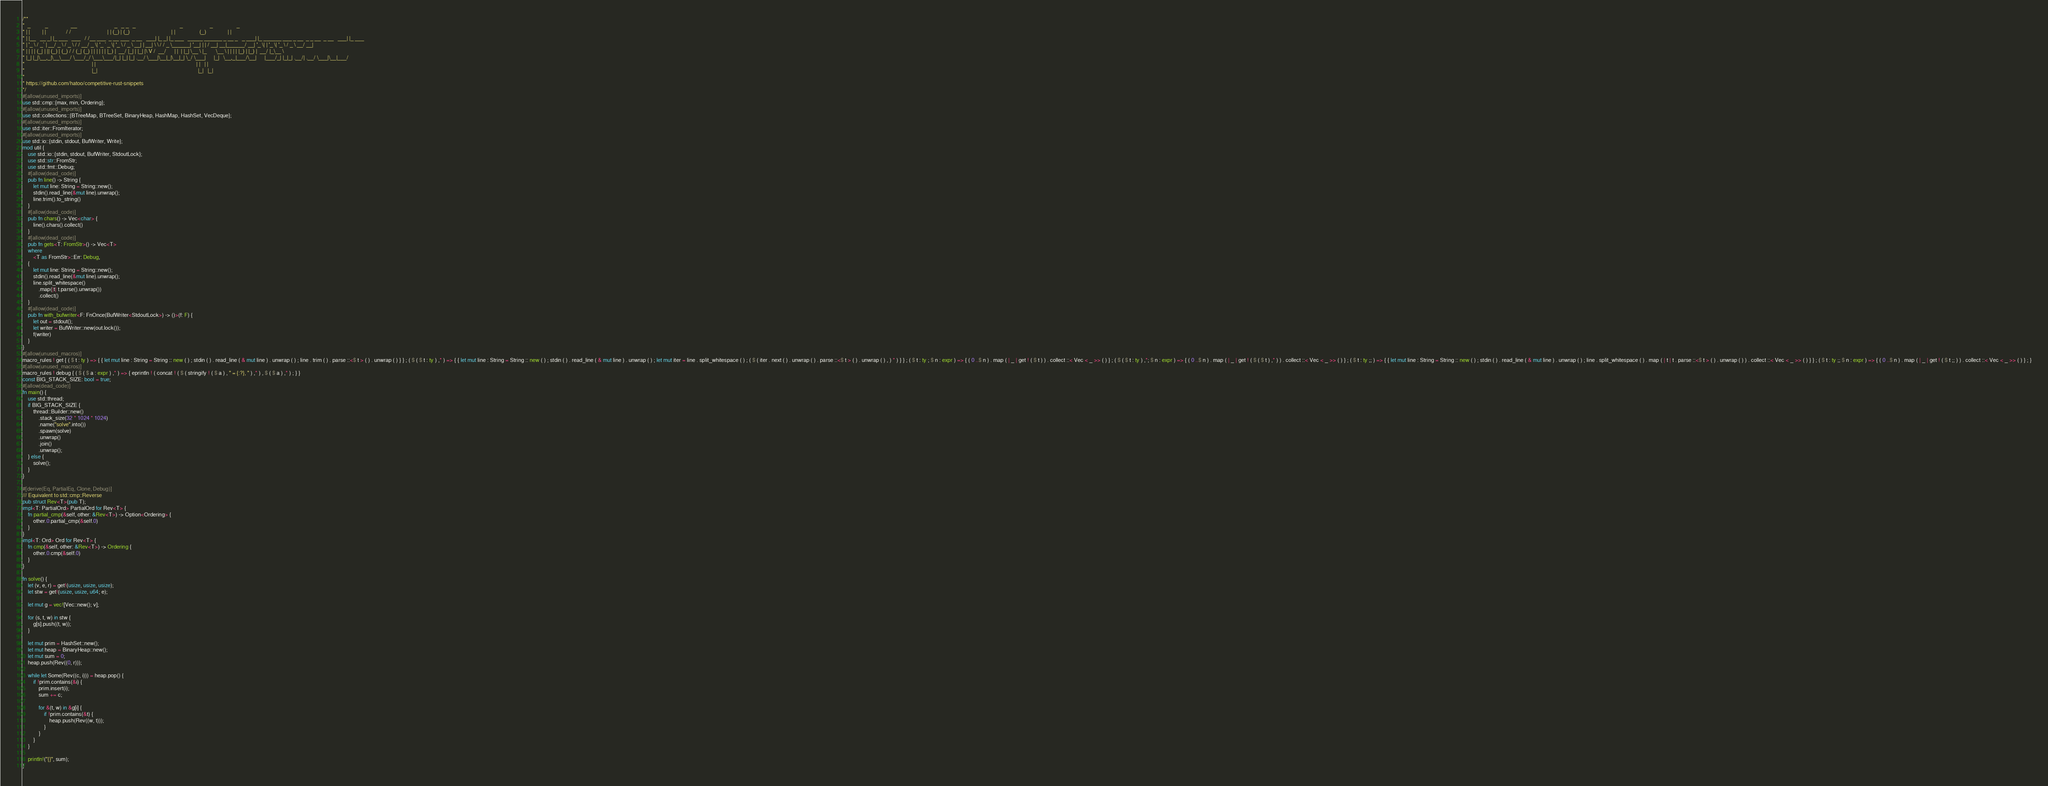Convert code to text. <code><loc_0><loc_0><loc_500><loc_500><_Rust_>/**
*  _           _                 __                            _   _ _   _                                 _                    _                  _
* | |         | |               / /                           | | (_) | (_)                               | |                  (_)                | |
* | |__   __ _| |_ ___   ___   / /__ ___  _ __ ___  _ __   ___| |_ _| |_ ___   _____ ______ _ __ _   _ ___| |_ ______ ___ _ __  _ _ __  _ __   ___| |_ ___
* | '_ \ / _` | __/ _ \ / _ \ / / __/ _ \| '_ ` _ \| '_ \ / _ \ __| | __| \ \ / / _ \______| '__| | | / __| __|______/ __| '_ \| | '_ \| '_ \ / _ \ __/ __|
* | | | | (_| | || (_) | (_) / / (_| (_) | | | | | | |_) |  __/ |_| | |_| |\ V /  __/      | |  | |_| \__ \ |_       \__ \ | | | | |_) | |_) |  __/ |_\__ \
* |_| |_|\__,_|\__\___/ \___/_/ \___\___/|_| |_| |_| .__/ \___|\__|_|\__|_| \_/ \___|      |_|   \__,_|___/\__|      |___/_| |_|_| .__/| .__/ \___|\__|___/
*                                                  | |                                                                           | |   | |
*                                                  |_|                                                                           |_|   |_|
*
* https://github.com/hatoo/competitive-rust-snippets
*/
#[allow(unused_imports)]
use std::cmp::{max, min, Ordering};
#[allow(unused_imports)]
use std::collections::{BTreeMap, BTreeSet, BinaryHeap, HashMap, HashSet, VecDeque};
#[allow(unused_imports)]
use std::iter::FromIterator;
#[allow(unused_imports)]
use std::io::{stdin, stdout, BufWriter, Write};
mod util {
    use std::io::{stdin, stdout, BufWriter, StdoutLock};
    use std::str::FromStr;
    use std::fmt::Debug;
    #[allow(dead_code)]
    pub fn line() -> String {
        let mut line: String = String::new();
        stdin().read_line(&mut line).unwrap();
        line.trim().to_string()
    }
    #[allow(dead_code)]
    pub fn chars() -> Vec<char> {
        line().chars().collect()
    }
    #[allow(dead_code)]
    pub fn gets<T: FromStr>() -> Vec<T>
    where
        <T as FromStr>::Err: Debug,
    {
        let mut line: String = String::new();
        stdin().read_line(&mut line).unwrap();
        line.split_whitespace()
            .map(|t| t.parse().unwrap())
            .collect()
    }
    #[allow(dead_code)]
    pub fn with_bufwriter<F: FnOnce(BufWriter<StdoutLock>) -> ()>(f: F) {
        let out = stdout();
        let writer = BufWriter::new(out.lock());
        f(writer)
    }
}
#[allow(unused_macros)]
macro_rules ! get { ( $ t : ty ) => { { let mut line : String = String :: new ( ) ; stdin ( ) . read_line ( & mut line ) . unwrap ( ) ; line . trim ( ) . parse ::<$ t > ( ) . unwrap ( ) } } ; ( $ ( $ t : ty ) ,* ) => { { let mut line : String = String :: new ( ) ; stdin ( ) . read_line ( & mut line ) . unwrap ( ) ; let mut iter = line . split_whitespace ( ) ; ( $ ( iter . next ( ) . unwrap ( ) . parse ::<$ t > ( ) . unwrap ( ) , ) * ) } } ; ( $ t : ty ; $ n : expr ) => { ( 0 ..$ n ) . map ( | _ | get ! ( $ t ) ) . collect ::< Vec < _ >> ( ) } ; ( $ ( $ t : ty ) ,*; $ n : expr ) => { ( 0 ..$ n ) . map ( | _ | get ! ( $ ( $ t ) ,* ) ) . collect ::< Vec < _ >> ( ) } ; ( $ t : ty ;; ) => { { let mut line : String = String :: new ( ) ; stdin ( ) . read_line ( & mut line ) . unwrap ( ) ; line . split_whitespace ( ) . map ( | t | t . parse ::<$ t > ( ) . unwrap ( ) ) . collect ::< Vec < _ >> ( ) } } ; ( $ t : ty ;; $ n : expr ) => { ( 0 ..$ n ) . map ( | _ | get ! ( $ t ;; ) ) . collect ::< Vec < _ >> ( ) } ; }
#[allow(unused_macros)]
macro_rules ! debug { ( $ ( $ a : expr ) ,* ) => { eprintln ! ( concat ! ( $ ( stringify ! ( $ a ) , " = {:?}, " ) ,* ) , $ ( $ a ) ,* ) ; } }
const BIG_STACK_SIZE: bool = true;
#[allow(dead_code)]
fn main() {
    use std::thread;
    if BIG_STACK_SIZE {
        thread::Builder::new()
            .stack_size(32 * 1024 * 1024)
            .name("solve".into())
            .spawn(solve)
            .unwrap()
            .join()
            .unwrap();
    } else {
        solve();
    }
}

#[derive(Eq, PartialEq, Clone, Debug)]
/// Equivalent to std::cmp::Reverse
pub struct Rev<T>(pub T);
impl<T: PartialOrd> PartialOrd for Rev<T> {
    fn partial_cmp(&self, other: &Rev<T>) -> Option<Ordering> {
        other.0.partial_cmp(&self.0)
    }
}
impl<T: Ord> Ord for Rev<T> {
    fn cmp(&self, other: &Rev<T>) -> Ordering {
        other.0.cmp(&self.0)
    }
}

fn solve() {
    let (v, e, r) = get!(usize, usize, usize);
    let stw = get!(usize, usize, u64; e);

    let mut g = vec![Vec::new(); v];

    for (s, t, w) in stw {
        g[s].push((t, w));
    }

    let mut prim = HashSet::new();
    let mut heap = BinaryHeap::new();
    let mut sum = 0;
    heap.push(Rev((0, r)));

    while let Some(Rev((c, i))) = heap.pop() {
        if !prim.contains(&i) {
            prim.insert(i);
            sum += c;

            for &(t, w) in &g[i] {
                if !prim.contains(&t) {
                    heap.push(Rev((w, t)));
                }
            }
        }
    }

    println!("{}", sum);
}

</code> 